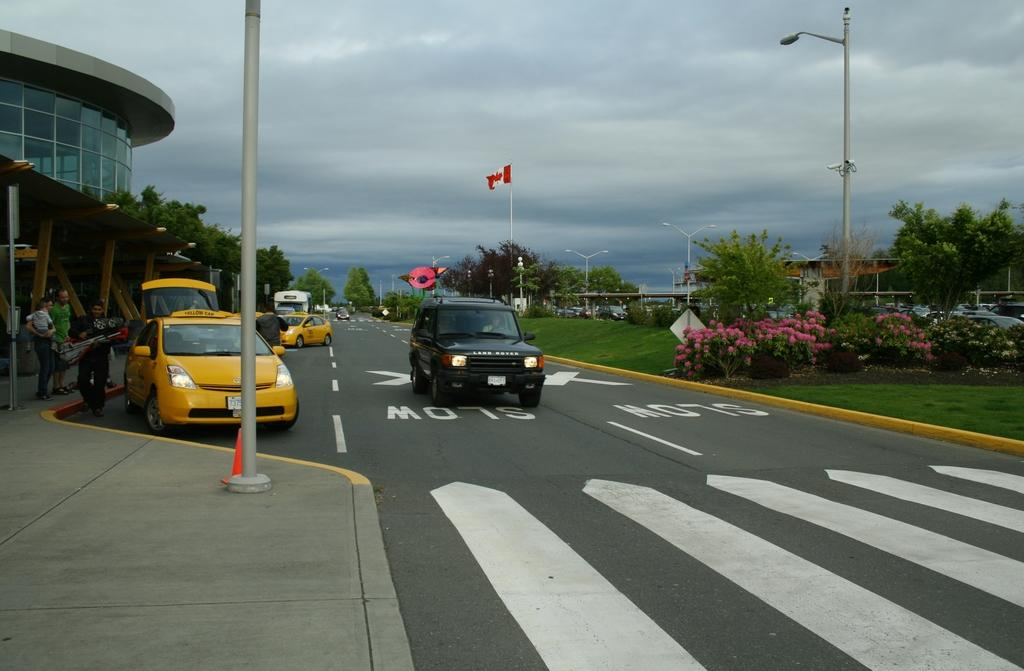Provide a one-sentence caption for the provided image. A black Rand Rover drives in the slow area of the road. 